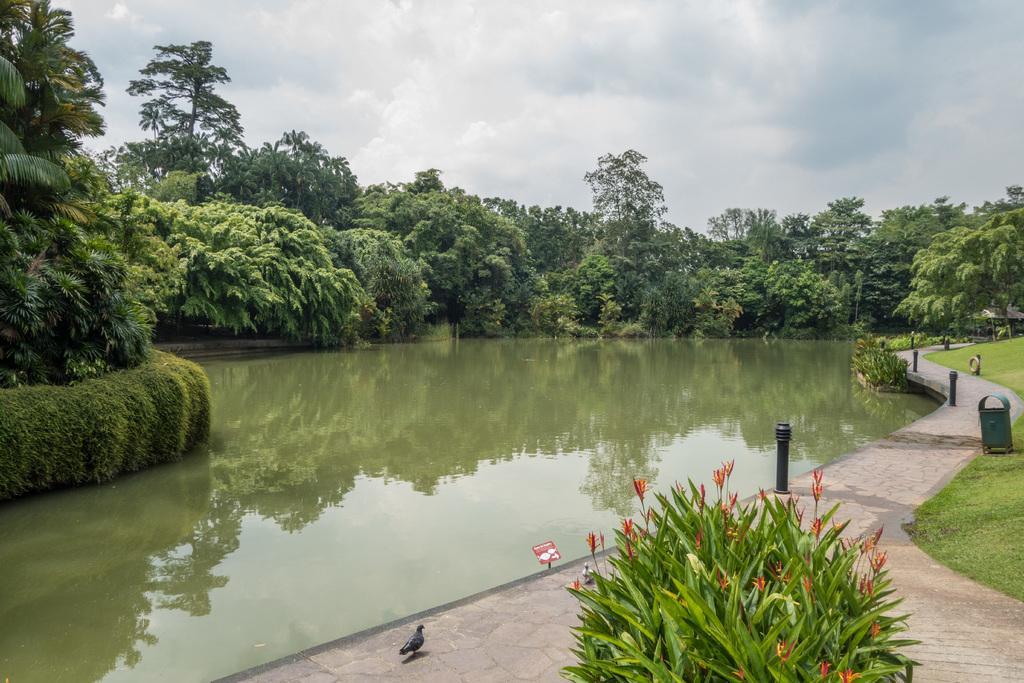Could you give a brief overview of what you see in this image? In this image, we can see some water. There are a few trees and plants. We can also see some grass. We can see the ground with some objects. There are a few poles. We can also see a bird and a board. We can see the reflection of trees in the water. We can also see the sky with clouds. 